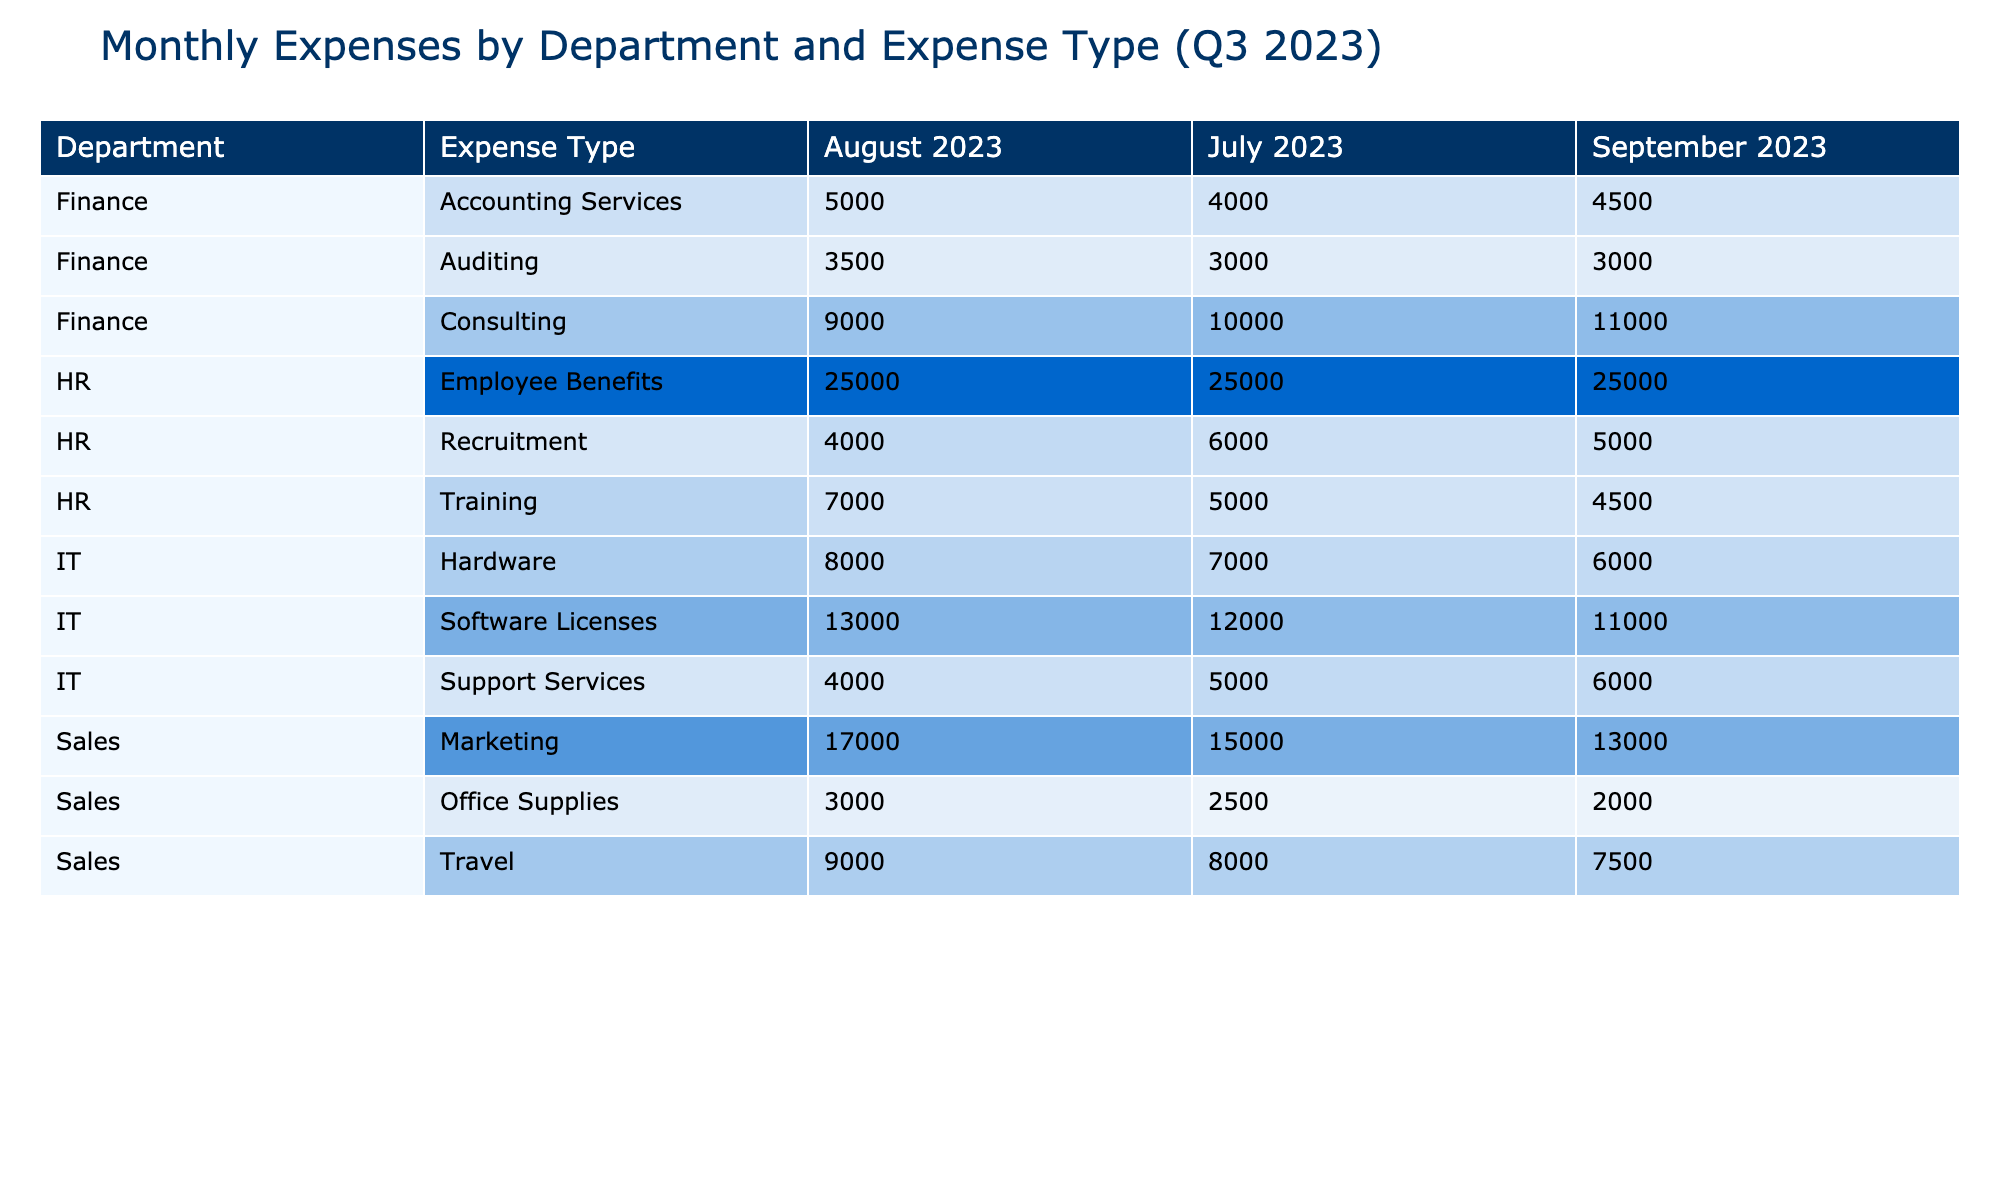What was the total expense for the HR department in September 2023? To find the total expense for the HR department in September 2023, we gather the values from all expense types under the HR department for that month: Recruitment (5000) + Training (4500) + Employee Benefits (25000). Adding these gives us 5000 + 4500 + 25000 = 34500.
Answer: 34500 Which expense type incurred the highest amount in August 2023? In August 2023, we review all expense types across different departments. The highest values are as follows: Marketing (17000), Travel (9000), Office Supplies (3000), Recruitment (4000), Training (7000), Employee Benefits (25000), Software Licenses (13000), Hardware (8000), Support Services (4000), Accounting Services (5000), Auditing (3500), and Consulting (9000). The maximum value is 25000 for Employee Benefits.
Answer: Employee Benefits Was there a decrease in total expenses for the IT department from July to September 2023? To calculate the total expenses for the IT department in each month, we add the values: July (12000 + 7000 + 5000 = 24000), August (13000 + 8000 + 4000 = 29000), and September (11000 + 6000 + 6000 = 23000). Comparing July (24000) to September (23000), us find a decrease of 1000.
Answer: Yes What is the average expense for the Sales department across all months? The total expenses for the Sales department across the three months are as follows: July (15000 + 8000 + 2500 = 25500), August (17000 + 9000 + 3000 = 29000), and September (13000 + 7500 + 2000 = 22500). Summing these gives 25500 + 29000 + 22500 = 77000. The average is calculated by dividing the total by the number of months: 77000 / 3 = 25666.67.
Answer: 25666.67 Did the total Marketing expense for the Sales department increase from July to August 2023? The Marketing expenses for July is 15000, and for August, it is 17000. Comparing these two values, we see that August (17000) is greater than July (15000), indicating an increase.
Answer: Yes 